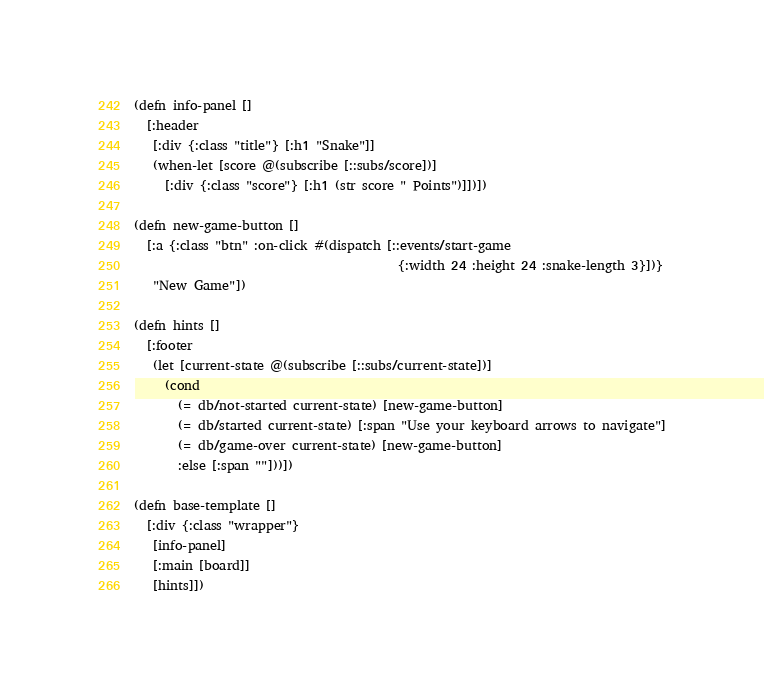<code> <loc_0><loc_0><loc_500><loc_500><_Clojure_>

(defn info-panel []
  [:header
   [:div {:class "title"} [:h1 "Snake"]]
   (when-let [score @(subscribe [::subs/score])]
     [:div {:class "score"} [:h1 (str score " Points")]])])

(defn new-game-button []
  [:a {:class "btn" :on-click #(dispatch [::events/start-game
                                          {:width 24 :height 24 :snake-length 3}])}
   "New Game"])

(defn hints []
  [:footer
   (let [current-state @(subscribe [::subs/current-state])]
     (cond
       (= db/not-started current-state) [new-game-button]
       (= db/started current-state) [:span "Use your keyboard arrows to navigate"]
       (= db/game-over current-state) [new-game-button]
       :else [:span ""]))])

(defn base-template []
  [:div {:class "wrapper"}
   [info-panel]
   [:main [board]]
   [hints]])
</code> 